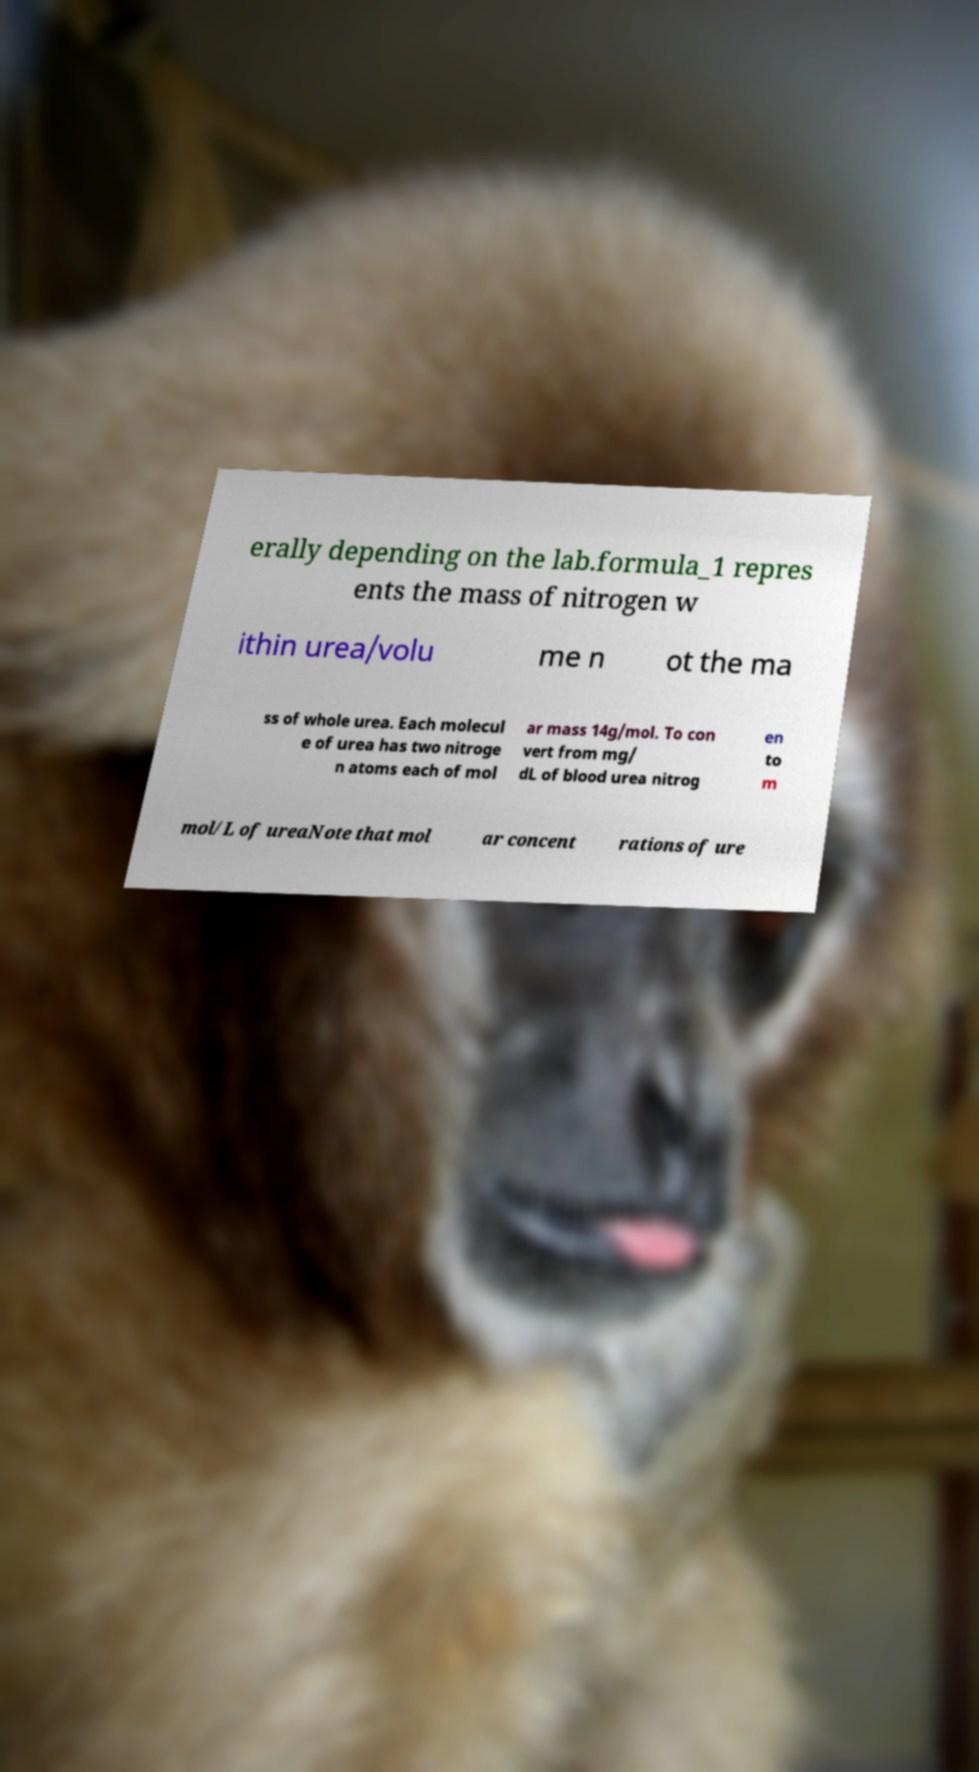What messages or text are displayed in this image? I need them in a readable, typed format. erally depending on the lab.formula_1 repres ents the mass of nitrogen w ithin urea/volu me n ot the ma ss of whole urea. Each molecul e of urea has two nitroge n atoms each of mol ar mass 14g/mol. To con vert from mg/ dL of blood urea nitrog en to m mol/L of ureaNote that mol ar concent rations of ure 